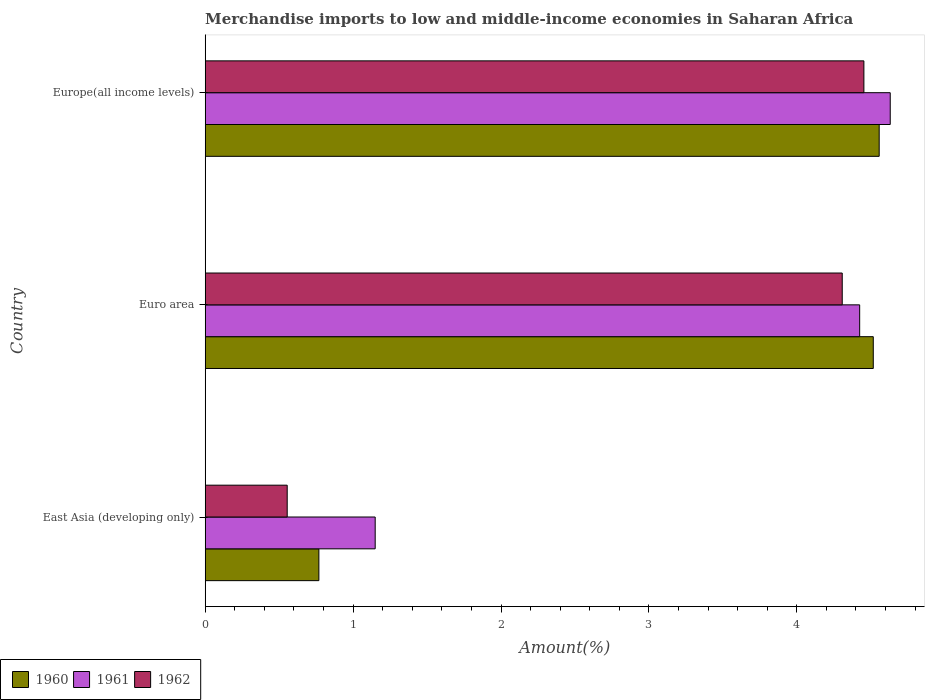Are the number of bars per tick equal to the number of legend labels?
Ensure brevity in your answer.  Yes. What is the label of the 3rd group of bars from the top?
Provide a short and direct response. East Asia (developing only). What is the percentage of amount earned from merchandise imports in 1960 in East Asia (developing only)?
Offer a very short reply. 0.77. Across all countries, what is the maximum percentage of amount earned from merchandise imports in 1962?
Make the answer very short. 4.45. Across all countries, what is the minimum percentage of amount earned from merchandise imports in 1960?
Give a very brief answer. 0.77. In which country was the percentage of amount earned from merchandise imports in 1960 maximum?
Provide a succinct answer. Europe(all income levels). In which country was the percentage of amount earned from merchandise imports in 1962 minimum?
Give a very brief answer. East Asia (developing only). What is the total percentage of amount earned from merchandise imports in 1961 in the graph?
Ensure brevity in your answer.  10.21. What is the difference between the percentage of amount earned from merchandise imports in 1962 in East Asia (developing only) and that in Euro area?
Make the answer very short. -3.75. What is the difference between the percentage of amount earned from merchandise imports in 1961 in Europe(all income levels) and the percentage of amount earned from merchandise imports in 1960 in East Asia (developing only)?
Offer a terse response. 3.86. What is the average percentage of amount earned from merchandise imports in 1961 per country?
Your answer should be very brief. 3.4. What is the difference between the percentage of amount earned from merchandise imports in 1962 and percentage of amount earned from merchandise imports in 1961 in Euro area?
Your answer should be very brief. -0.12. What is the ratio of the percentage of amount earned from merchandise imports in 1962 in East Asia (developing only) to that in Euro area?
Keep it short and to the point. 0.13. Is the percentage of amount earned from merchandise imports in 1960 in East Asia (developing only) less than that in Euro area?
Ensure brevity in your answer.  Yes. What is the difference between the highest and the second highest percentage of amount earned from merchandise imports in 1961?
Keep it short and to the point. 0.21. What is the difference between the highest and the lowest percentage of amount earned from merchandise imports in 1960?
Your response must be concise. 3.79. Is the sum of the percentage of amount earned from merchandise imports in 1960 in East Asia (developing only) and Europe(all income levels) greater than the maximum percentage of amount earned from merchandise imports in 1962 across all countries?
Your answer should be very brief. Yes. What does the 3rd bar from the top in Euro area represents?
Provide a succinct answer. 1960. What does the 2nd bar from the bottom in Euro area represents?
Your response must be concise. 1961. Does the graph contain any zero values?
Ensure brevity in your answer.  No. How many legend labels are there?
Provide a short and direct response. 3. What is the title of the graph?
Make the answer very short. Merchandise imports to low and middle-income economies in Saharan Africa. What is the label or title of the X-axis?
Offer a very short reply. Amount(%). What is the Amount(%) in 1960 in East Asia (developing only)?
Ensure brevity in your answer.  0.77. What is the Amount(%) of 1961 in East Asia (developing only)?
Ensure brevity in your answer.  1.15. What is the Amount(%) in 1962 in East Asia (developing only)?
Give a very brief answer. 0.55. What is the Amount(%) of 1960 in Euro area?
Ensure brevity in your answer.  4.52. What is the Amount(%) of 1961 in Euro area?
Make the answer very short. 4.43. What is the Amount(%) in 1962 in Euro area?
Offer a terse response. 4.31. What is the Amount(%) of 1960 in Europe(all income levels)?
Offer a terse response. 4.56. What is the Amount(%) of 1961 in Europe(all income levels)?
Offer a terse response. 4.63. What is the Amount(%) in 1962 in Europe(all income levels)?
Give a very brief answer. 4.45. Across all countries, what is the maximum Amount(%) of 1960?
Ensure brevity in your answer.  4.56. Across all countries, what is the maximum Amount(%) of 1961?
Give a very brief answer. 4.63. Across all countries, what is the maximum Amount(%) in 1962?
Your answer should be very brief. 4.45. Across all countries, what is the minimum Amount(%) of 1960?
Provide a succinct answer. 0.77. Across all countries, what is the minimum Amount(%) in 1961?
Your response must be concise. 1.15. Across all countries, what is the minimum Amount(%) in 1962?
Keep it short and to the point. 0.55. What is the total Amount(%) of 1960 in the graph?
Provide a short and direct response. 9.84. What is the total Amount(%) of 1961 in the graph?
Your response must be concise. 10.21. What is the total Amount(%) in 1962 in the graph?
Ensure brevity in your answer.  9.32. What is the difference between the Amount(%) of 1960 in East Asia (developing only) and that in Euro area?
Your response must be concise. -3.75. What is the difference between the Amount(%) in 1961 in East Asia (developing only) and that in Euro area?
Keep it short and to the point. -3.28. What is the difference between the Amount(%) in 1962 in East Asia (developing only) and that in Euro area?
Provide a succinct answer. -3.75. What is the difference between the Amount(%) in 1960 in East Asia (developing only) and that in Europe(all income levels)?
Ensure brevity in your answer.  -3.79. What is the difference between the Amount(%) of 1961 in East Asia (developing only) and that in Europe(all income levels)?
Provide a short and direct response. -3.48. What is the difference between the Amount(%) in 1962 in East Asia (developing only) and that in Europe(all income levels)?
Your answer should be very brief. -3.9. What is the difference between the Amount(%) in 1960 in Euro area and that in Europe(all income levels)?
Offer a very short reply. -0.04. What is the difference between the Amount(%) in 1961 in Euro area and that in Europe(all income levels)?
Ensure brevity in your answer.  -0.21. What is the difference between the Amount(%) in 1962 in Euro area and that in Europe(all income levels)?
Offer a terse response. -0.15. What is the difference between the Amount(%) of 1960 in East Asia (developing only) and the Amount(%) of 1961 in Euro area?
Provide a short and direct response. -3.66. What is the difference between the Amount(%) in 1960 in East Asia (developing only) and the Amount(%) in 1962 in Euro area?
Offer a very short reply. -3.54. What is the difference between the Amount(%) of 1961 in East Asia (developing only) and the Amount(%) of 1962 in Euro area?
Your answer should be compact. -3.16. What is the difference between the Amount(%) in 1960 in East Asia (developing only) and the Amount(%) in 1961 in Europe(all income levels)?
Offer a very short reply. -3.86. What is the difference between the Amount(%) in 1960 in East Asia (developing only) and the Amount(%) in 1962 in Europe(all income levels)?
Give a very brief answer. -3.68. What is the difference between the Amount(%) in 1961 in East Asia (developing only) and the Amount(%) in 1962 in Europe(all income levels)?
Offer a very short reply. -3.3. What is the difference between the Amount(%) of 1960 in Euro area and the Amount(%) of 1961 in Europe(all income levels)?
Your response must be concise. -0.11. What is the difference between the Amount(%) of 1960 in Euro area and the Amount(%) of 1962 in Europe(all income levels)?
Your answer should be very brief. 0.06. What is the difference between the Amount(%) of 1961 in Euro area and the Amount(%) of 1962 in Europe(all income levels)?
Offer a very short reply. -0.03. What is the average Amount(%) of 1960 per country?
Give a very brief answer. 3.28. What is the average Amount(%) of 1961 per country?
Your response must be concise. 3.4. What is the average Amount(%) in 1962 per country?
Your response must be concise. 3.11. What is the difference between the Amount(%) of 1960 and Amount(%) of 1961 in East Asia (developing only)?
Offer a terse response. -0.38. What is the difference between the Amount(%) of 1960 and Amount(%) of 1962 in East Asia (developing only)?
Your answer should be compact. 0.21. What is the difference between the Amount(%) of 1961 and Amount(%) of 1962 in East Asia (developing only)?
Provide a short and direct response. 0.59. What is the difference between the Amount(%) in 1960 and Amount(%) in 1961 in Euro area?
Offer a very short reply. 0.09. What is the difference between the Amount(%) of 1960 and Amount(%) of 1962 in Euro area?
Provide a succinct answer. 0.21. What is the difference between the Amount(%) of 1961 and Amount(%) of 1962 in Euro area?
Provide a short and direct response. 0.12. What is the difference between the Amount(%) in 1960 and Amount(%) in 1961 in Europe(all income levels)?
Offer a very short reply. -0.07. What is the difference between the Amount(%) of 1960 and Amount(%) of 1962 in Europe(all income levels)?
Your answer should be very brief. 0.1. What is the difference between the Amount(%) in 1961 and Amount(%) in 1962 in Europe(all income levels)?
Offer a very short reply. 0.18. What is the ratio of the Amount(%) in 1960 in East Asia (developing only) to that in Euro area?
Your answer should be very brief. 0.17. What is the ratio of the Amount(%) of 1961 in East Asia (developing only) to that in Euro area?
Give a very brief answer. 0.26. What is the ratio of the Amount(%) of 1962 in East Asia (developing only) to that in Euro area?
Provide a short and direct response. 0.13. What is the ratio of the Amount(%) of 1960 in East Asia (developing only) to that in Europe(all income levels)?
Your answer should be compact. 0.17. What is the ratio of the Amount(%) of 1961 in East Asia (developing only) to that in Europe(all income levels)?
Provide a short and direct response. 0.25. What is the ratio of the Amount(%) of 1962 in East Asia (developing only) to that in Europe(all income levels)?
Offer a very short reply. 0.12. What is the ratio of the Amount(%) in 1960 in Euro area to that in Europe(all income levels)?
Offer a very short reply. 0.99. What is the ratio of the Amount(%) of 1961 in Euro area to that in Europe(all income levels)?
Your answer should be very brief. 0.96. What is the ratio of the Amount(%) of 1962 in Euro area to that in Europe(all income levels)?
Your answer should be compact. 0.97. What is the difference between the highest and the second highest Amount(%) in 1960?
Your answer should be very brief. 0.04. What is the difference between the highest and the second highest Amount(%) in 1961?
Ensure brevity in your answer.  0.21. What is the difference between the highest and the second highest Amount(%) of 1962?
Your response must be concise. 0.15. What is the difference between the highest and the lowest Amount(%) in 1960?
Keep it short and to the point. 3.79. What is the difference between the highest and the lowest Amount(%) in 1961?
Offer a very short reply. 3.48. What is the difference between the highest and the lowest Amount(%) of 1962?
Provide a succinct answer. 3.9. 